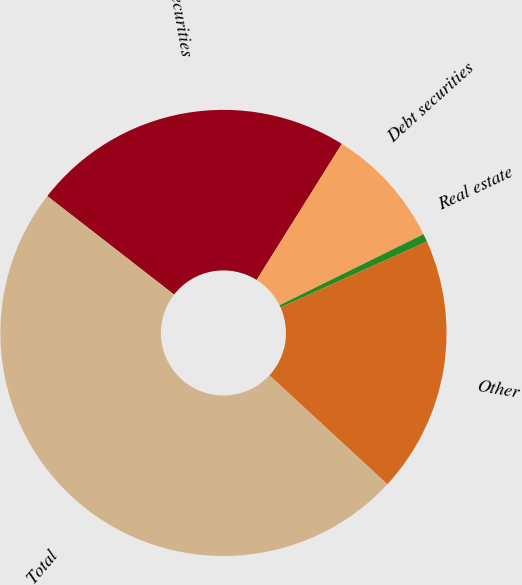<chart> <loc_0><loc_0><loc_500><loc_500><pie_chart><fcel>Equity securities<fcel>Debt securities<fcel>Real estate<fcel>Other<fcel>Total<nl><fcel>23.39%<fcel>8.8%<fcel>0.58%<fcel>18.58%<fcel>48.64%<nl></chart> 